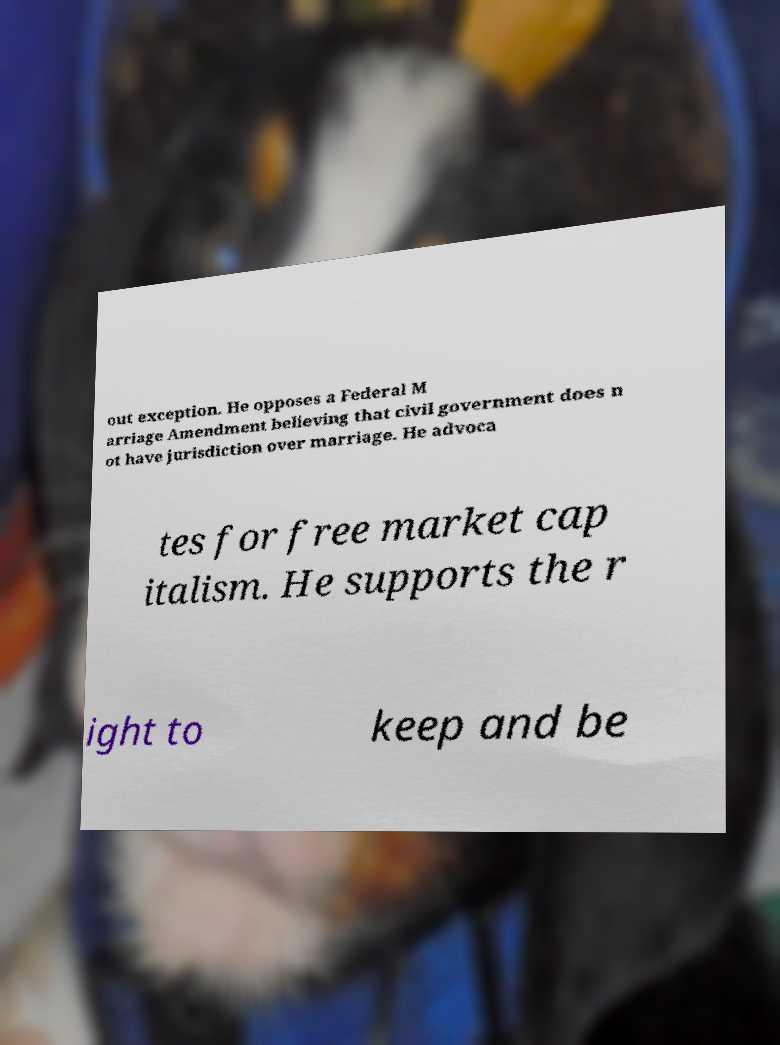Could you assist in decoding the text presented in this image and type it out clearly? out exception. He opposes a Federal M arriage Amendment believing that civil government does n ot have jurisdiction over marriage. He advoca tes for free market cap italism. He supports the r ight to keep and be 